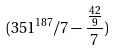<formula> <loc_0><loc_0><loc_500><loc_500>( 3 5 1 ^ { 1 8 7 } / 7 - \frac { \frac { 4 2 } { 9 } } { 7 } )</formula> 